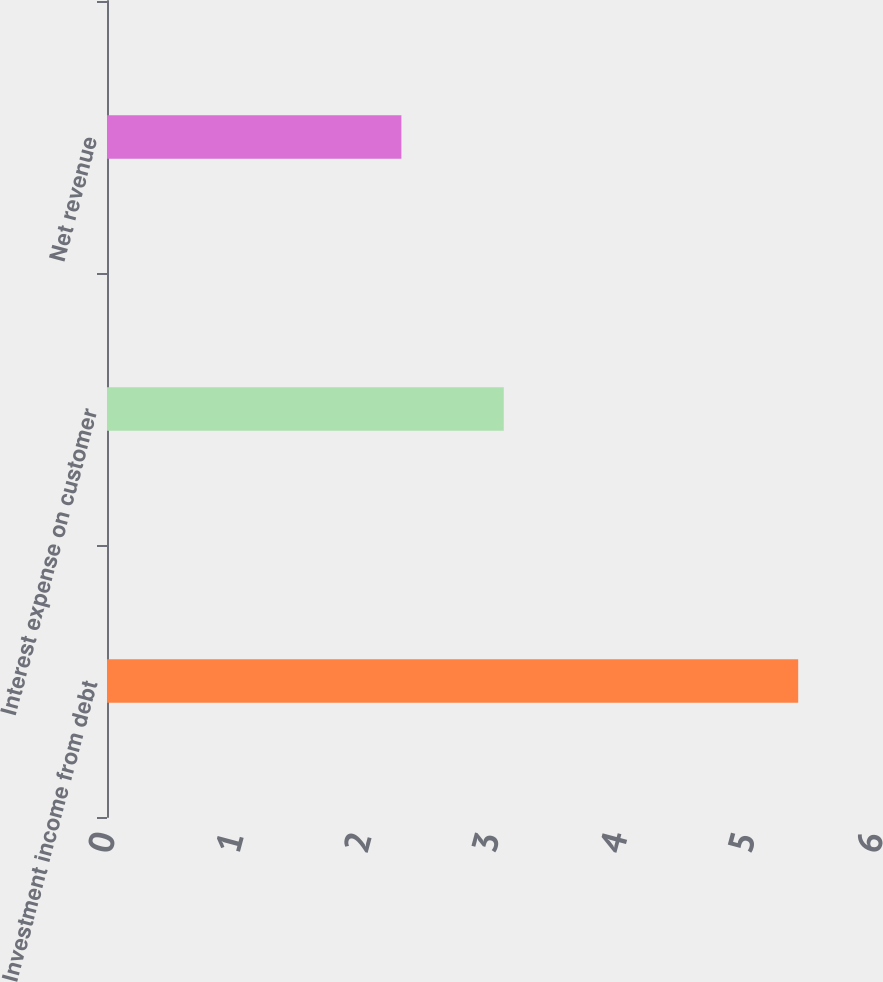Convert chart. <chart><loc_0><loc_0><loc_500><loc_500><bar_chart><fcel>Investment income from debt<fcel>Interest expense on customer<fcel>Net revenue<nl><fcel>5.4<fcel>3.1<fcel>2.3<nl></chart> 